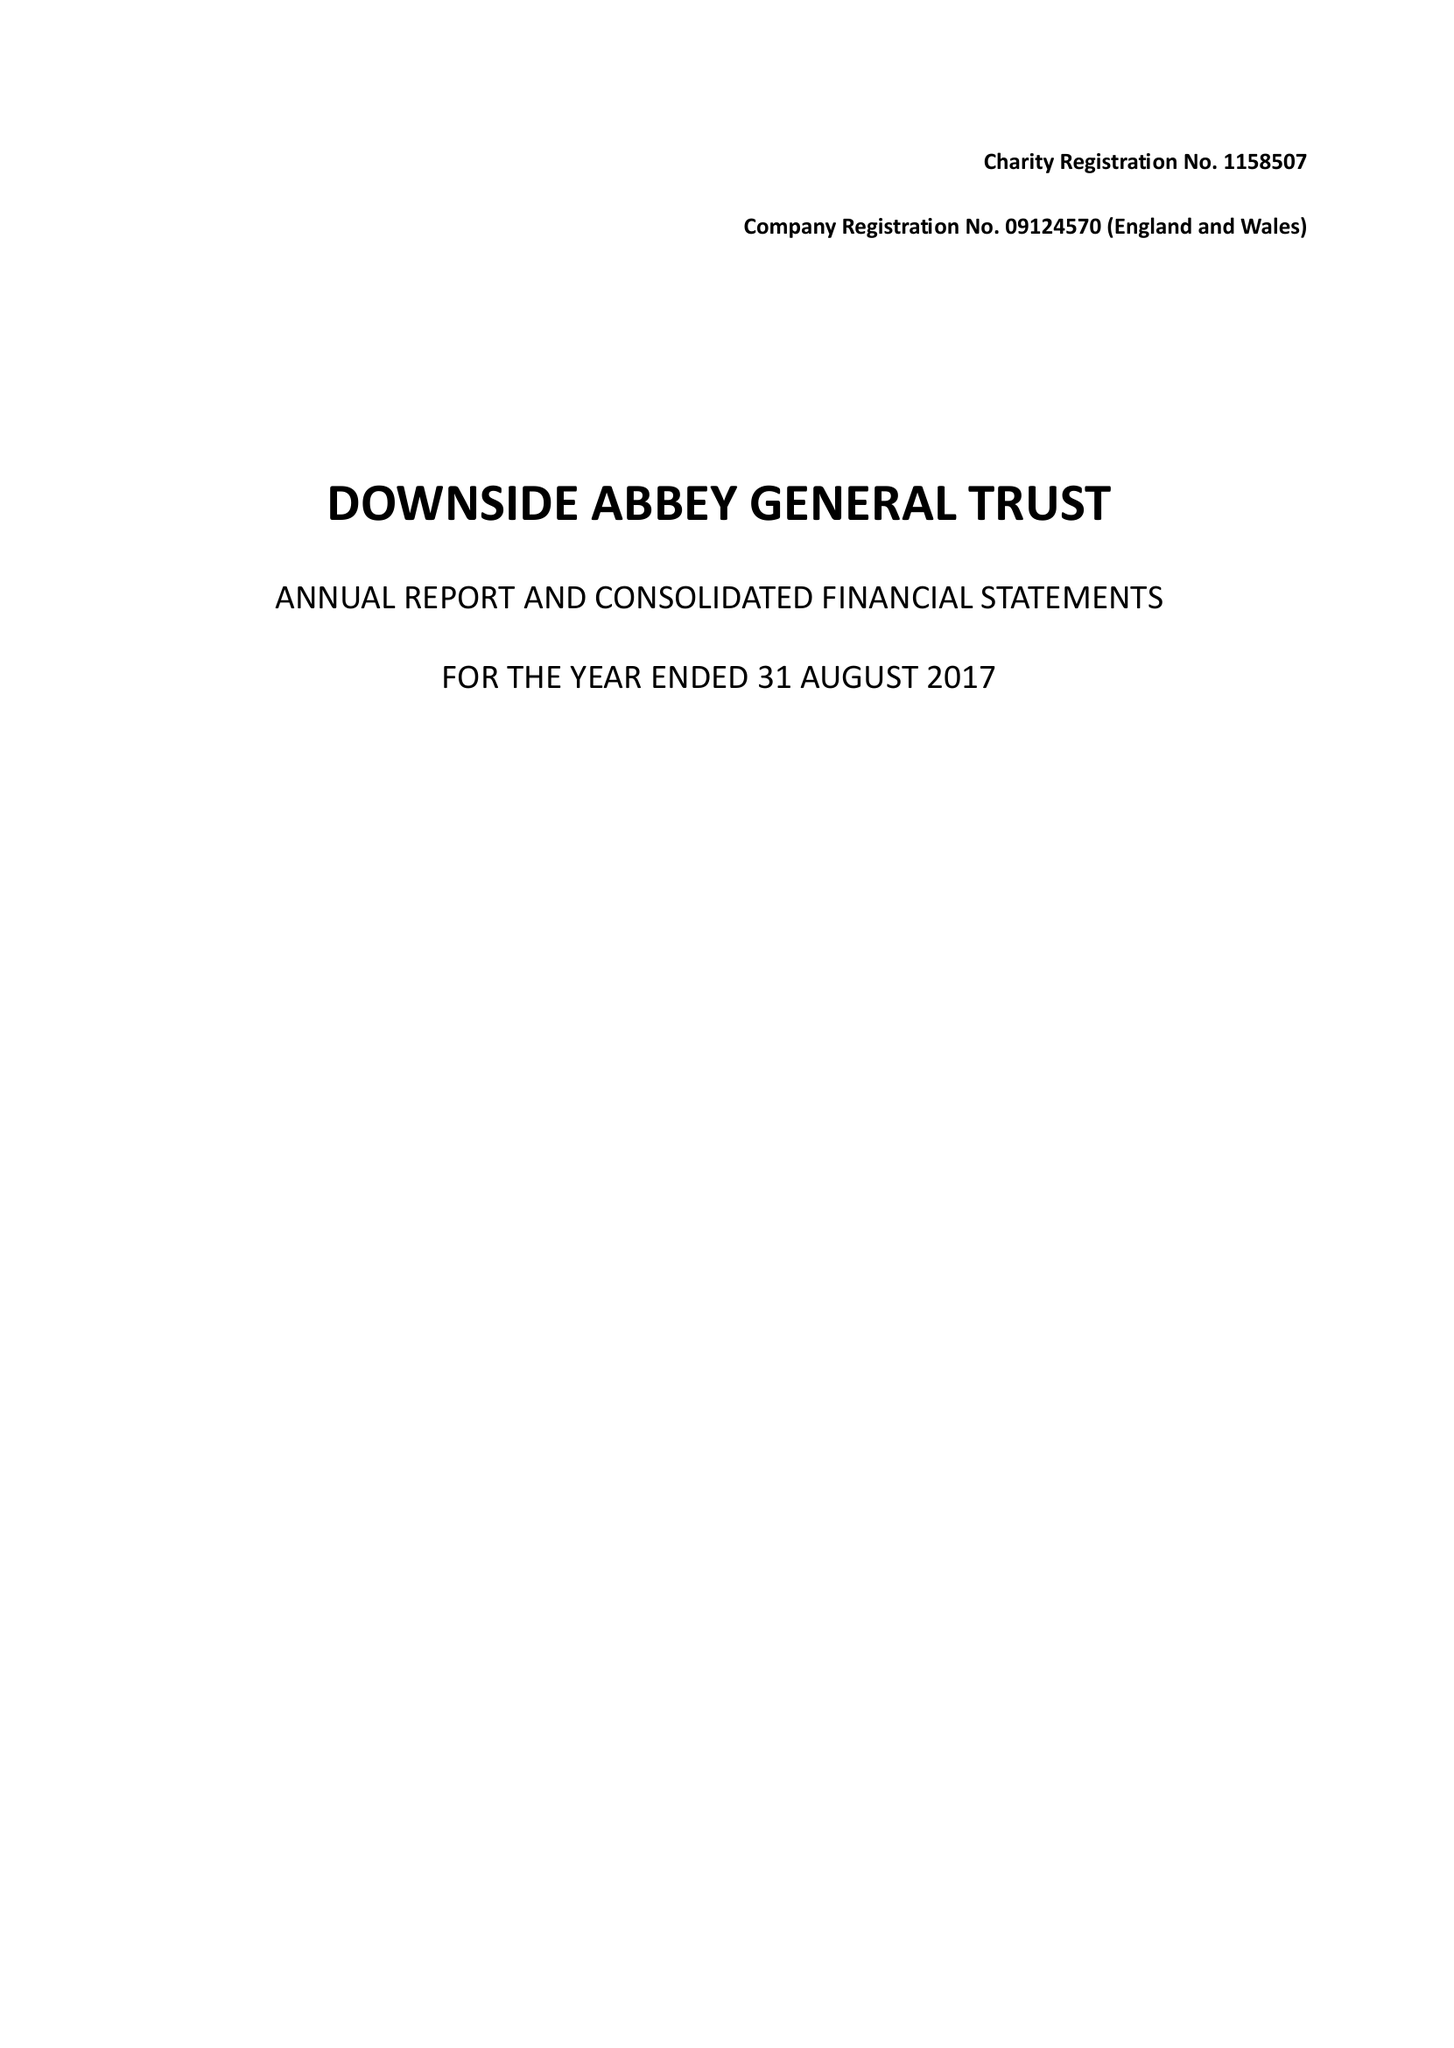What is the value for the charity_number?
Answer the question using a single word or phrase. 1158507 